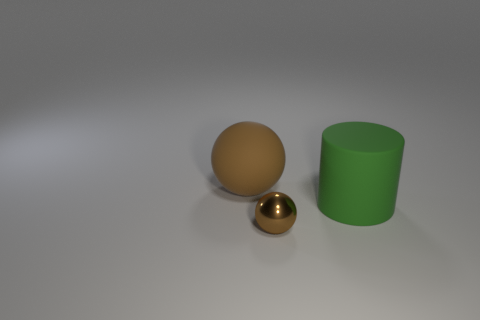Add 1 large brown balls. How many objects exist? 4 Subtract all cylinders. How many objects are left? 2 Add 1 large purple things. How many large purple things exist? 1 Subtract 0 brown cylinders. How many objects are left? 3 Subtract all tiny green matte cubes. Subtract all green things. How many objects are left? 2 Add 2 large brown balls. How many large brown balls are left? 3 